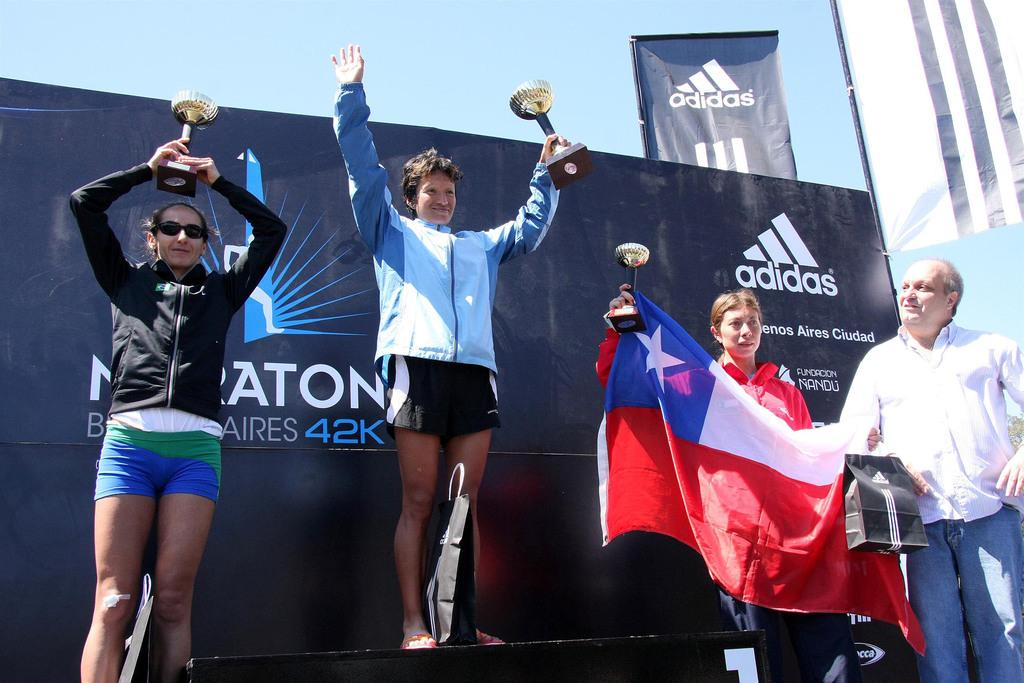<image>
Summarize the visual content of the image. Several athletes stand in front of a banner sponsored by Adidas. 